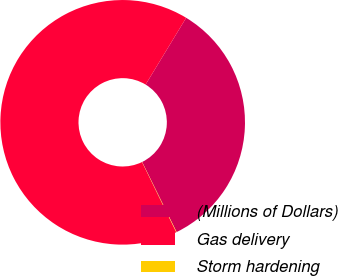<chart> <loc_0><loc_0><loc_500><loc_500><pie_chart><fcel>(Millions of Dollars)<fcel>Gas delivery<fcel>Storm hardening<nl><fcel>34.04%<fcel>65.91%<fcel>0.05%<nl></chart> 